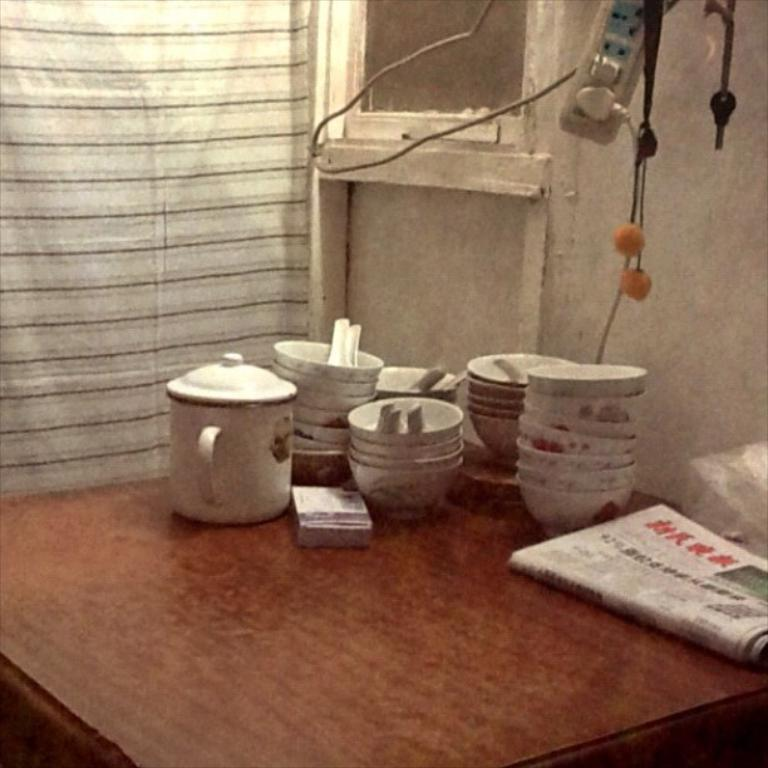What objects are on the table in the image? There are bowls and a kettle on the table in the image. What else can be seen on the table? A newspaper is present on the table. Can you describe the extension visible at the top right of the image? There is an extension visible at the right top of the image. What type of silver is used to make the jelly in the image? There is no jelly or silver present in the image. 